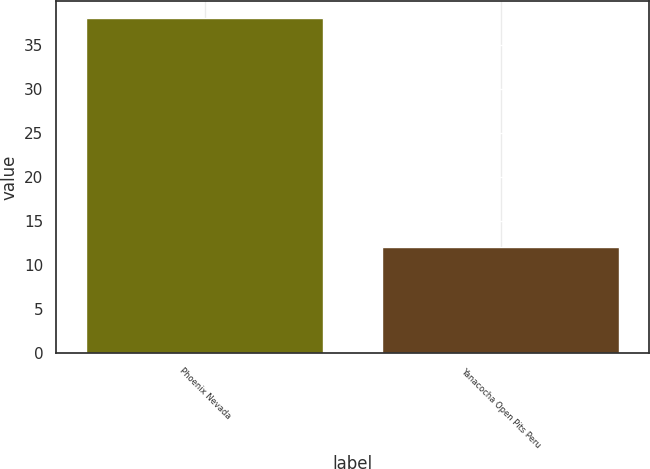Convert chart. <chart><loc_0><loc_0><loc_500><loc_500><bar_chart><fcel>Phoenix Nevada<fcel>Yanacocha Open Pits Peru<nl><fcel>38<fcel>12<nl></chart> 